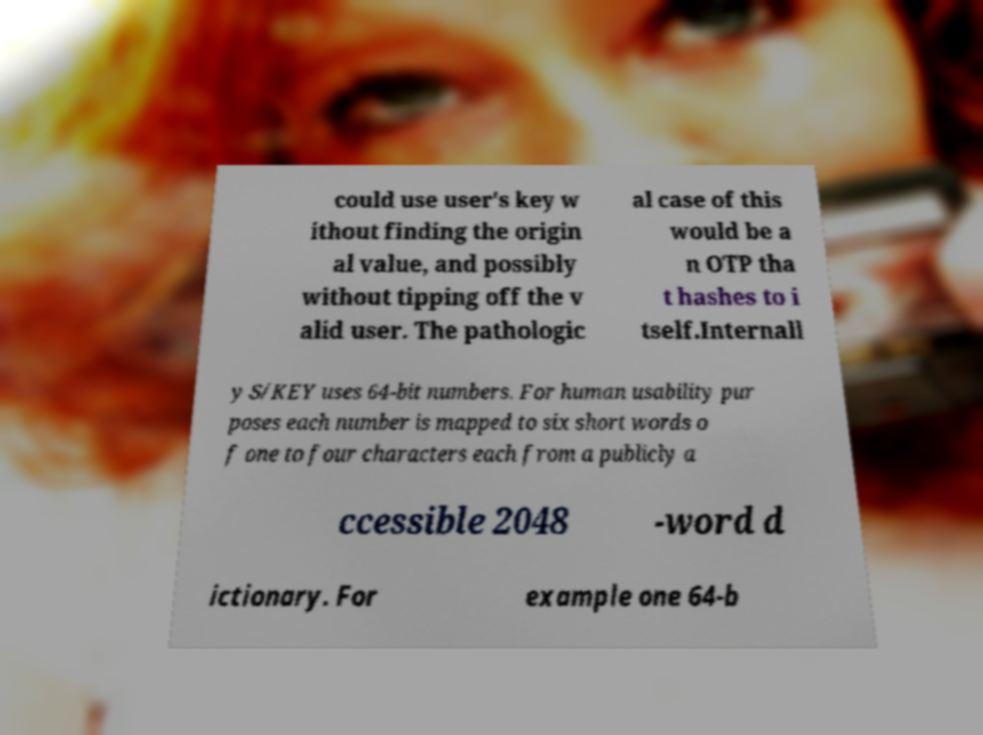Can you accurately transcribe the text from the provided image for me? could use user's key w ithout finding the origin al value, and possibly without tipping off the v alid user. The pathologic al case of this would be a n OTP tha t hashes to i tself.Internall y S/KEY uses 64-bit numbers. For human usability pur poses each number is mapped to six short words o f one to four characters each from a publicly a ccessible 2048 -word d ictionary. For example one 64-b 